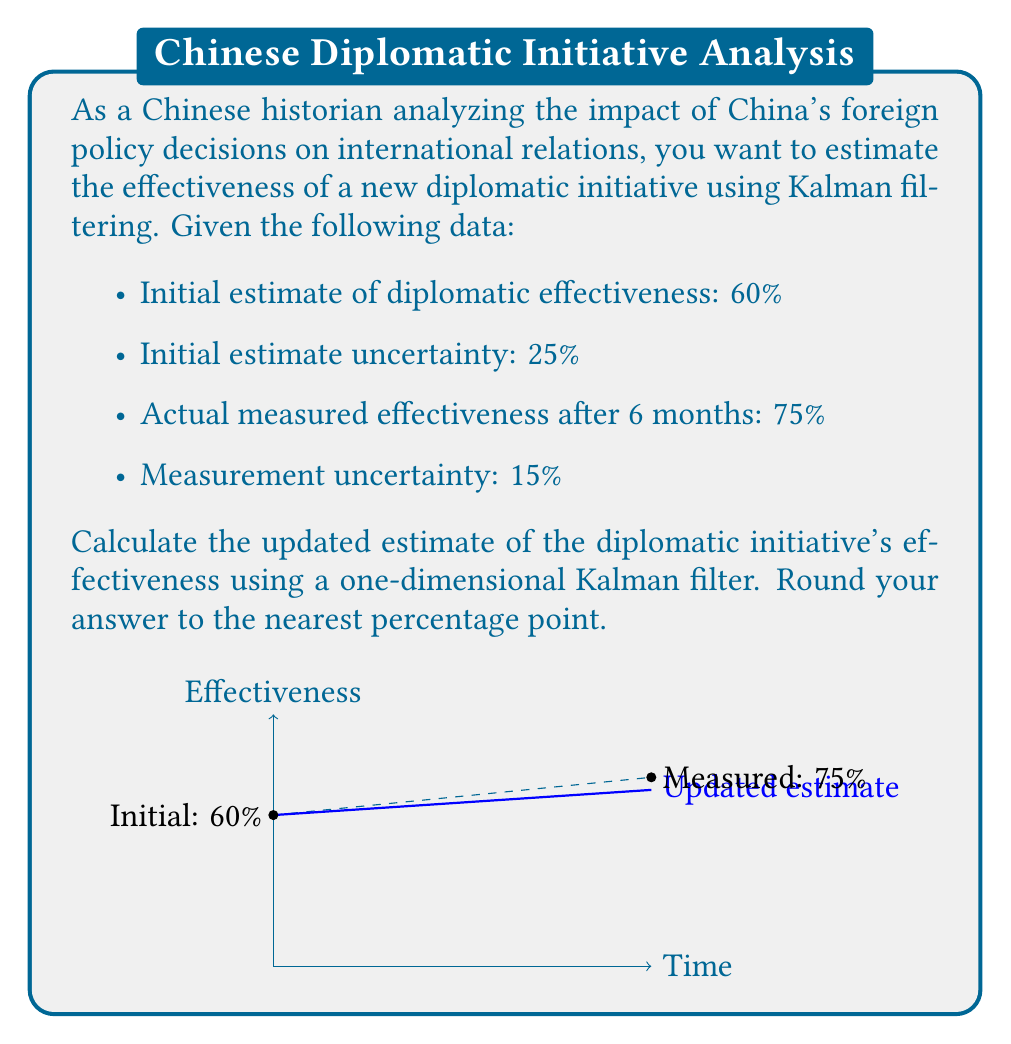Solve this math problem. To solve this problem using a one-dimensional Kalman filter, we'll follow these steps:

1) Define the variables:
   $x_0 = 60\%$ (initial estimate)
   $P_0 = 25\%$ (initial uncertainty)
   $z = 75\%$ (measurement)
   $R = 15\%$ (measurement uncertainty)

2) Calculate the Kalman gain (K):
   $$K = \frac{P_0}{P_0 + R} = \frac{25}{25 + 15} = \frac{25}{40} = 0.625$$

3) Update the estimate:
   $$x_1 = x_0 + K(z - x_0)$$
   $$x_1 = 60\% + 0.625(75\% - 60\%)$$
   $$x_1 = 60\% + 0.625(15\%)$$
   $$x_1 = 60\% + 9.375\%$$
   $$x_1 = 69.375\%$$

4) Update the uncertainty:
   $$P_1 = (1 - K)P_0$$
   $$P_1 = (1 - 0.625) * 25\%$$
   $$P_1 = 0.375 * 25\% = 9.375\%$$

5) Round the result to the nearest percentage point:
   69.375% rounds to 69%

The Kalman filter combines the initial estimate with the new measurement, weighing each by their relative uncertainties. The result is a more accurate estimate than either the initial guess or the single measurement alone.
Answer: 69% 